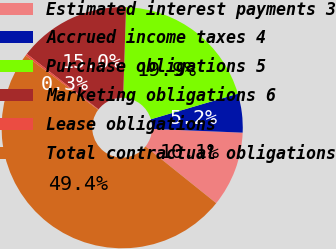Convert chart. <chart><loc_0><loc_0><loc_500><loc_500><pie_chart><fcel>Estimated interest payments 3<fcel>Accrued income taxes 4<fcel>Purchase obligations 5<fcel>Marketing obligations 6<fcel>Lease obligations<fcel>Total contractual obligations<nl><fcel>10.11%<fcel>5.2%<fcel>19.94%<fcel>15.03%<fcel>0.28%<fcel>49.43%<nl></chart> 